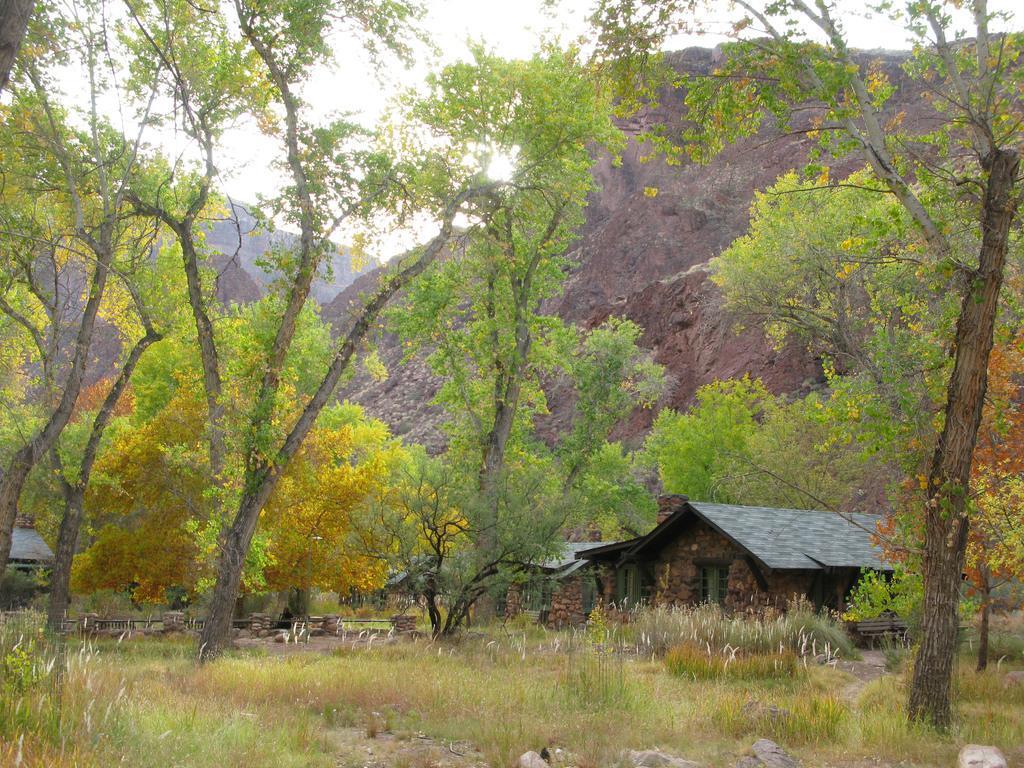Describe this image in one or two sentences. In the image we can see there are rocks and plants on the ground. There are hut shaped buildings and behind there are trees. There are rock hills at the back and there is a clear sky. 